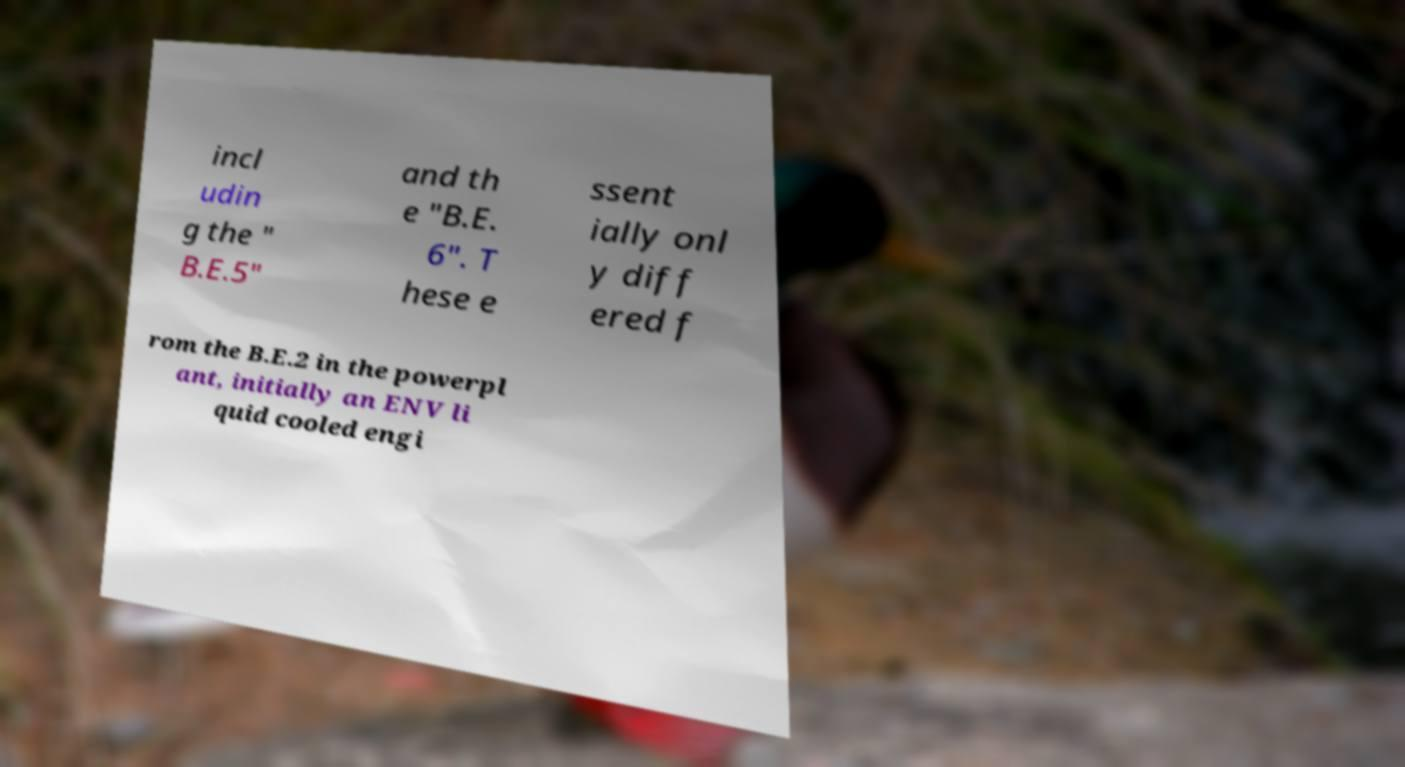For documentation purposes, I need the text within this image transcribed. Could you provide that? incl udin g the " B.E.5" and th e "B.E. 6". T hese e ssent ially onl y diff ered f rom the B.E.2 in the powerpl ant, initially an ENV li quid cooled engi 